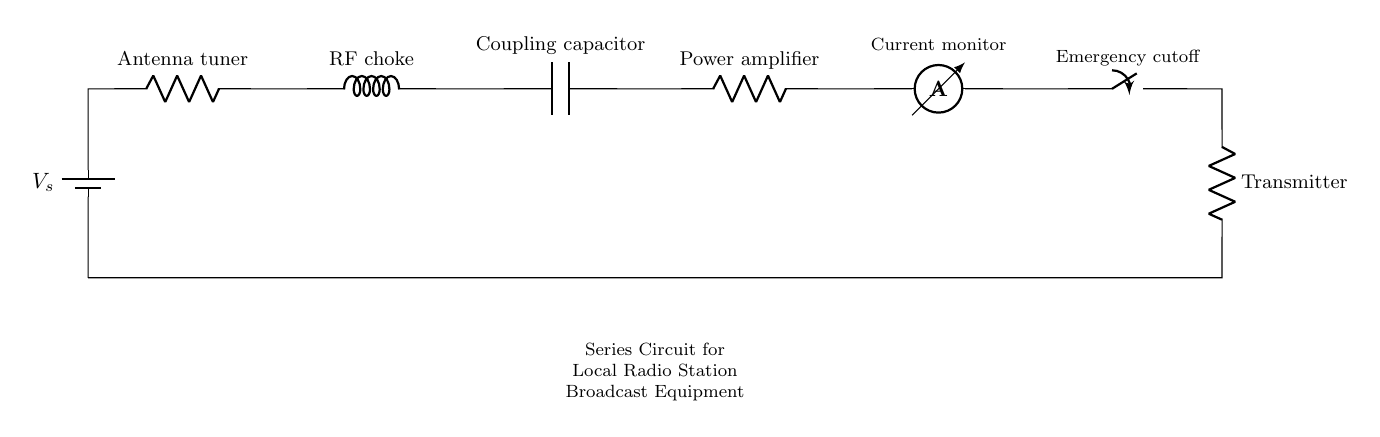What is the type of circuit displayed? The circuit is a series circuit, as all components are arranged in a single path for current flow.
Answer: series circuit How many components are in the circuit? There are six main components: Battery, Antenna tuner, RF choke, Coupling capacitor, Power amplifier, and Transmitter, along with an ammeter and emergency switch, totaling eight.
Answer: eight What does the emergency cutoff switch do? The emergency cutoff switch is used to disconnect power in case of an emergency, providing safety for the circuit.
Answer: disconnect power Which component is used to monitor current? The ammeter is the component that measures the current flowing through the circuit.
Answer: ammeter What is the function of the RF choke? The RF choke functions to block high-frequency signals while allowing lower frequencies to pass, helping to control signal characteristics in the circuit.
Answer: block high-frequency signals How would you describe the direction of current flow in this circuit? In a series circuit, the current flows in a single direction through each component in the order they are connected.
Answer: single direction What happens to voltage across each component in a series circuit? In a series circuit, the total voltage is divided among the components, so each component has a different voltage drop based on its resistance and impedance.
Answer: divided voltage 